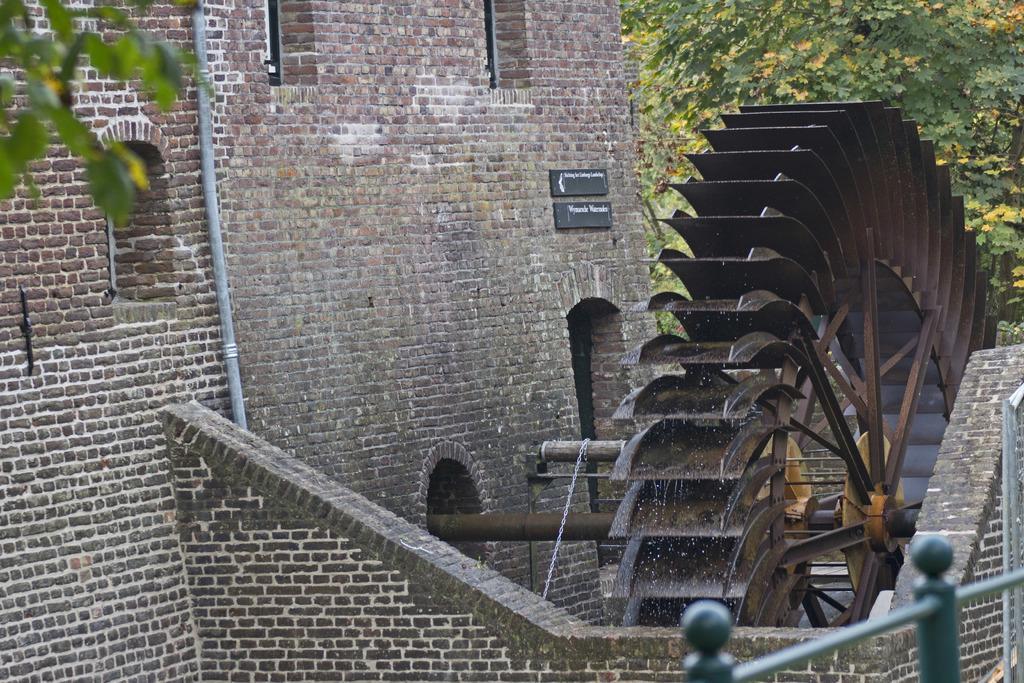Can you describe this image briefly? In the middle of the image we can see a building, on the building there is a machine. Behind the machine there is a tree. In the bottom right corner of the image there is fencing. 